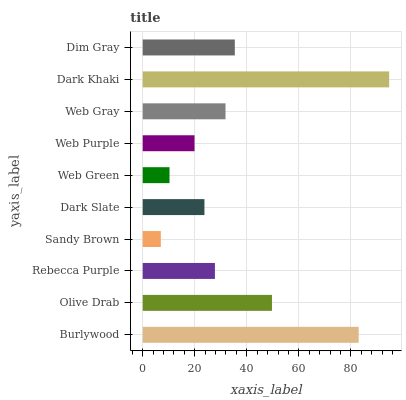Is Sandy Brown the minimum?
Answer yes or no. Yes. Is Dark Khaki the maximum?
Answer yes or no. Yes. Is Olive Drab the minimum?
Answer yes or no. No. Is Olive Drab the maximum?
Answer yes or no. No. Is Burlywood greater than Olive Drab?
Answer yes or no. Yes. Is Olive Drab less than Burlywood?
Answer yes or no. Yes. Is Olive Drab greater than Burlywood?
Answer yes or no. No. Is Burlywood less than Olive Drab?
Answer yes or no. No. Is Web Gray the high median?
Answer yes or no. Yes. Is Rebecca Purple the low median?
Answer yes or no. Yes. Is Web Purple the high median?
Answer yes or no. No. Is Burlywood the low median?
Answer yes or no. No. 